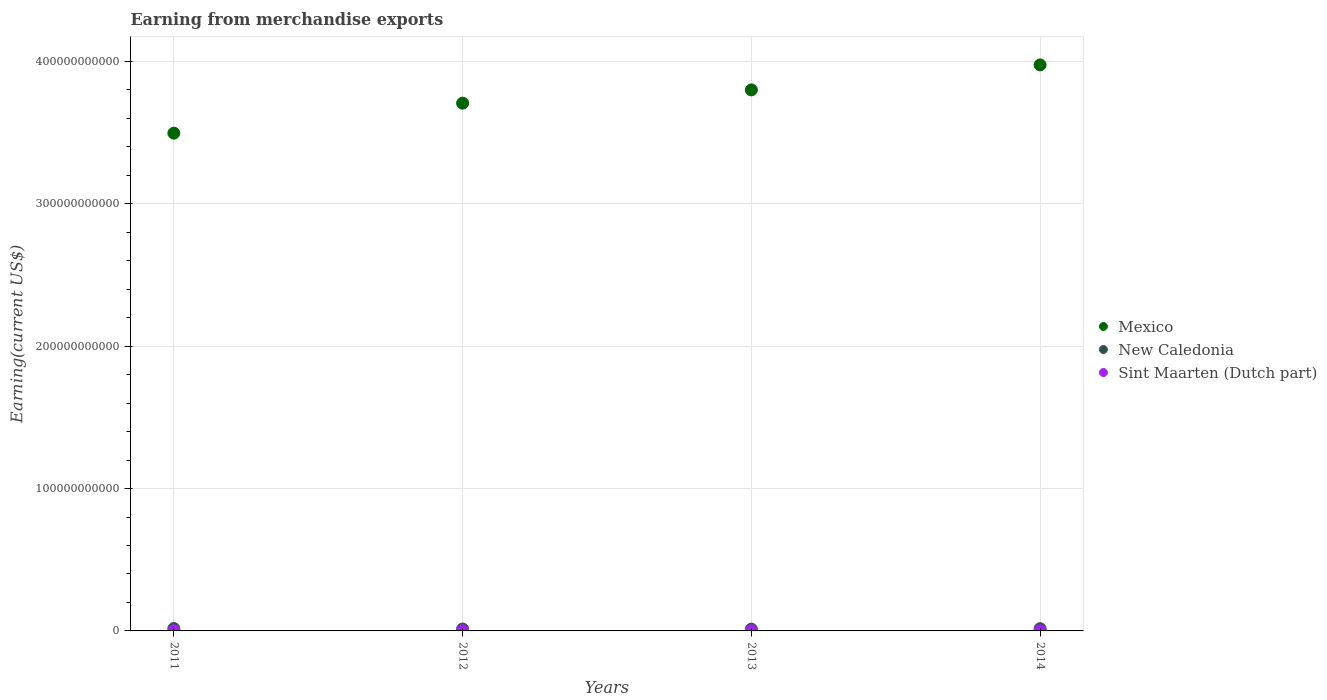How many different coloured dotlines are there?
Give a very brief answer. 3. Is the number of dotlines equal to the number of legend labels?
Provide a succinct answer. Yes. What is the amount earned from merchandise exports in Sint Maarten (Dutch part) in 2014?
Keep it short and to the point. 1.30e+08. Across all years, what is the maximum amount earned from merchandise exports in Mexico?
Ensure brevity in your answer.  3.98e+11. Across all years, what is the minimum amount earned from merchandise exports in New Caledonia?
Provide a succinct answer. 1.24e+09. In which year was the amount earned from merchandise exports in Mexico maximum?
Ensure brevity in your answer.  2014. In which year was the amount earned from merchandise exports in Mexico minimum?
Make the answer very short. 2011. What is the total amount earned from merchandise exports in New Caledonia in the graph?
Make the answer very short. 5.80e+09. What is the difference between the amount earned from merchandise exports in New Caledonia in 2013 and that in 2014?
Your response must be concise. -3.23e+08. What is the difference between the amount earned from merchandise exports in New Caledonia in 2011 and the amount earned from merchandise exports in Mexico in 2013?
Your response must be concise. -3.78e+11. What is the average amount earned from merchandise exports in New Caledonia per year?
Ensure brevity in your answer.  1.45e+09. In the year 2014, what is the difference between the amount earned from merchandise exports in New Caledonia and amount earned from merchandise exports in Sint Maarten (Dutch part)?
Your answer should be very brief. 1.43e+09. What is the ratio of the amount earned from merchandise exports in Mexico in 2013 to that in 2014?
Keep it short and to the point. 0.96. Is the amount earned from merchandise exports in New Caledonia in 2011 less than that in 2012?
Your answer should be compact. No. What is the difference between the highest and the second highest amount earned from merchandise exports in Sint Maarten (Dutch part)?
Make the answer very short. 4.63e+07. What is the difference between the highest and the lowest amount earned from merchandise exports in Sint Maarten (Dutch part)?
Your answer should be compact. 5.01e+07. Is the sum of the amount earned from merchandise exports in Mexico in 2012 and 2013 greater than the maximum amount earned from merchandise exports in Sint Maarten (Dutch part) across all years?
Provide a short and direct response. Yes. Is the amount earned from merchandise exports in New Caledonia strictly greater than the amount earned from merchandise exports in Sint Maarten (Dutch part) over the years?
Give a very brief answer. Yes. Is the amount earned from merchandise exports in New Caledonia strictly less than the amount earned from merchandise exports in Sint Maarten (Dutch part) over the years?
Provide a succinct answer. No. How many years are there in the graph?
Your answer should be very brief. 4. What is the difference between two consecutive major ticks on the Y-axis?
Your answer should be compact. 1.00e+11. Are the values on the major ticks of Y-axis written in scientific E-notation?
Your answer should be compact. No. Does the graph contain any zero values?
Provide a short and direct response. No. Where does the legend appear in the graph?
Provide a short and direct response. Center right. What is the title of the graph?
Offer a very short reply. Earning from merchandise exports. What is the label or title of the Y-axis?
Your answer should be compact. Earning(current US$). What is the Earning(current US$) of Mexico in 2011?
Your response must be concise. 3.50e+11. What is the Earning(current US$) of New Caledonia in 2011?
Your answer should be very brief. 1.66e+09. What is the Earning(current US$) in Sint Maarten (Dutch part) in 2011?
Offer a very short reply. 1.27e+08. What is the Earning(current US$) in Mexico in 2012?
Offer a very short reply. 3.71e+11. What is the Earning(current US$) in New Caledonia in 2012?
Make the answer very short. 1.33e+09. What is the Earning(current US$) in Sint Maarten (Dutch part) in 2012?
Your answer should be very brief. 1.31e+08. What is the Earning(current US$) of Mexico in 2013?
Offer a very short reply. 3.80e+11. What is the Earning(current US$) of New Caledonia in 2013?
Provide a short and direct response. 1.24e+09. What is the Earning(current US$) in Sint Maarten (Dutch part) in 2013?
Your response must be concise. 1.77e+08. What is the Earning(current US$) of Mexico in 2014?
Offer a very short reply. 3.98e+11. What is the Earning(current US$) of New Caledonia in 2014?
Offer a very short reply. 1.56e+09. What is the Earning(current US$) in Sint Maarten (Dutch part) in 2014?
Give a very brief answer. 1.30e+08. Across all years, what is the maximum Earning(current US$) of Mexico?
Ensure brevity in your answer.  3.98e+11. Across all years, what is the maximum Earning(current US$) of New Caledonia?
Give a very brief answer. 1.66e+09. Across all years, what is the maximum Earning(current US$) in Sint Maarten (Dutch part)?
Provide a succinct answer. 1.77e+08. Across all years, what is the minimum Earning(current US$) of Mexico?
Your answer should be compact. 3.50e+11. Across all years, what is the minimum Earning(current US$) in New Caledonia?
Make the answer very short. 1.24e+09. Across all years, what is the minimum Earning(current US$) of Sint Maarten (Dutch part)?
Give a very brief answer. 1.27e+08. What is the total Earning(current US$) in Mexico in the graph?
Your response must be concise. 1.50e+12. What is the total Earning(current US$) of New Caledonia in the graph?
Your response must be concise. 5.80e+09. What is the total Earning(current US$) in Sint Maarten (Dutch part) in the graph?
Offer a very short reply. 5.65e+08. What is the difference between the Earning(current US$) in Mexico in 2011 and that in 2012?
Your answer should be very brief. -2.11e+1. What is the difference between the Earning(current US$) of New Caledonia in 2011 and that in 2012?
Your answer should be very brief. 3.36e+08. What is the difference between the Earning(current US$) of Sint Maarten (Dutch part) in 2011 and that in 2012?
Ensure brevity in your answer.  -3.82e+06. What is the difference between the Earning(current US$) of Mexico in 2011 and that in 2013?
Ensure brevity in your answer.  -3.04e+1. What is the difference between the Earning(current US$) in New Caledonia in 2011 and that in 2013?
Give a very brief answer. 4.21e+08. What is the difference between the Earning(current US$) in Sint Maarten (Dutch part) in 2011 and that in 2013?
Provide a succinct answer. -5.01e+07. What is the difference between the Earning(current US$) in Mexico in 2011 and that in 2014?
Offer a very short reply. -4.80e+1. What is the difference between the Earning(current US$) in New Caledonia in 2011 and that in 2014?
Make the answer very short. 9.79e+07. What is the difference between the Earning(current US$) in Sint Maarten (Dutch part) in 2011 and that in 2014?
Your answer should be very brief. -3.09e+06. What is the difference between the Earning(current US$) in Mexico in 2012 and that in 2013?
Your answer should be compact. -9.32e+09. What is the difference between the Earning(current US$) in New Caledonia in 2012 and that in 2013?
Keep it short and to the point. 8.41e+07. What is the difference between the Earning(current US$) in Sint Maarten (Dutch part) in 2012 and that in 2013?
Provide a succinct answer. -4.63e+07. What is the difference between the Earning(current US$) in Mexico in 2012 and that in 2014?
Provide a short and direct response. -2.69e+1. What is the difference between the Earning(current US$) in New Caledonia in 2012 and that in 2014?
Your answer should be compact. -2.38e+08. What is the difference between the Earning(current US$) in Sint Maarten (Dutch part) in 2012 and that in 2014?
Keep it short and to the point. 7.26e+05. What is the difference between the Earning(current US$) in Mexico in 2013 and that in 2014?
Your answer should be compact. -1.76e+1. What is the difference between the Earning(current US$) in New Caledonia in 2013 and that in 2014?
Your response must be concise. -3.23e+08. What is the difference between the Earning(current US$) of Sint Maarten (Dutch part) in 2013 and that in 2014?
Ensure brevity in your answer.  4.70e+07. What is the difference between the Earning(current US$) in Mexico in 2011 and the Earning(current US$) in New Caledonia in 2012?
Provide a short and direct response. 3.48e+11. What is the difference between the Earning(current US$) in Mexico in 2011 and the Earning(current US$) in Sint Maarten (Dutch part) in 2012?
Provide a short and direct response. 3.49e+11. What is the difference between the Earning(current US$) in New Caledonia in 2011 and the Earning(current US$) in Sint Maarten (Dutch part) in 2012?
Offer a very short reply. 1.53e+09. What is the difference between the Earning(current US$) in Mexico in 2011 and the Earning(current US$) in New Caledonia in 2013?
Offer a terse response. 3.48e+11. What is the difference between the Earning(current US$) in Mexico in 2011 and the Earning(current US$) in Sint Maarten (Dutch part) in 2013?
Your response must be concise. 3.49e+11. What is the difference between the Earning(current US$) of New Caledonia in 2011 and the Earning(current US$) of Sint Maarten (Dutch part) in 2013?
Give a very brief answer. 1.49e+09. What is the difference between the Earning(current US$) in Mexico in 2011 and the Earning(current US$) in New Caledonia in 2014?
Provide a short and direct response. 3.48e+11. What is the difference between the Earning(current US$) in Mexico in 2011 and the Earning(current US$) in Sint Maarten (Dutch part) in 2014?
Provide a short and direct response. 3.49e+11. What is the difference between the Earning(current US$) of New Caledonia in 2011 and the Earning(current US$) of Sint Maarten (Dutch part) in 2014?
Provide a succinct answer. 1.53e+09. What is the difference between the Earning(current US$) of Mexico in 2012 and the Earning(current US$) of New Caledonia in 2013?
Make the answer very short. 3.69e+11. What is the difference between the Earning(current US$) in Mexico in 2012 and the Earning(current US$) in Sint Maarten (Dutch part) in 2013?
Your response must be concise. 3.70e+11. What is the difference between the Earning(current US$) in New Caledonia in 2012 and the Earning(current US$) in Sint Maarten (Dutch part) in 2013?
Offer a very short reply. 1.15e+09. What is the difference between the Earning(current US$) in Mexico in 2012 and the Earning(current US$) in New Caledonia in 2014?
Offer a very short reply. 3.69e+11. What is the difference between the Earning(current US$) of Mexico in 2012 and the Earning(current US$) of Sint Maarten (Dutch part) in 2014?
Ensure brevity in your answer.  3.71e+11. What is the difference between the Earning(current US$) in New Caledonia in 2012 and the Earning(current US$) in Sint Maarten (Dutch part) in 2014?
Your answer should be very brief. 1.20e+09. What is the difference between the Earning(current US$) of Mexico in 2013 and the Earning(current US$) of New Caledonia in 2014?
Offer a very short reply. 3.78e+11. What is the difference between the Earning(current US$) of Mexico in 2013 and the Earning(current US$) of Sint Maarten (Dutch part) in 2014?
Your answer should be compact. 3.80e+11. What is the difference between the Earning(current US$) in New Caledonia in 2013 and the Earning(current US$) in Sint Maarten (Dutch part) in 2014?
Your answer should be very brief. 1.11e+09. What is the average Earning(current US$) of Mexico per year?
Provide a short and direct response. 3.74e+11. What is the average Earning(current US$) in New Caledonia per year?
Offer a terse response. 1.45e+09. What is the average Earning(current US$) of Sint Maarten (Dutch part) per year?
Make the answer very short. 1.41e+08. In the year 2011, what is the difference between the Earning(current US$) in Mexico and Earning(current US$) in New Caledonia?
Provide a succinct answer. 3.48e+11. In the year 2011, what is the difference between the Earning(current US$) of Mexico and Earning(current US$) of Sint Maarten (Dutch part)?
Provide a succinct answer. 3.49e+11. In the year 2011, what is the difference between the Earning(current US$) of New Caledonia and Earning(current US$) of Sint Maarten (Dutch part)?
Keep it short and to the point. 1.54e+09. In the year 2012, what is the difference between the Earning(current US$) of Mexico and Earning(current US$) of New Caledonia?
Your answer should be very brief. 3.69e+11. In the year 2012, what is the difference between the Earning(current US$) in Mexico and Earning(current US$) in Sint Maarten (Dutch part)?
Your answer should be very brief. 3.71e+11. In the year 2012, what is the difference between the Earning(current US$) of New Caledonia and Earning(current US$) of Sint Maarten (Dutch part)?
Ensure brevity in your answer.  1.20e+09. In the year 2013, what is the difference between the Earning(current US$) of Mexico and Earning(current US$) of New Caledonia?
Offer a terse response. 3.79e+11. In the year 2013, what is the difference between the Earning(current US$) in Mexico and Earning(current US$) in Sint Maarten (Dutch part)?
Provide a short and direct response. 3.80e+11. In the year 2013, what is the difference between the Earning(current US$) in New Caledonia and Earning(current US$) in Sint Maarten (Dutch part)?
Provide a short and direct response. 1.07e+09. In the year 2014, what is the difference between the Earning(current US$) of Mexico and Earning(current US$) of New Caledonia?
Provide a succinct answer. 3.96e+11. In the year 2014, what is the difference between the Earning(current US$) of Mexico and Earning(current US$) of Sint Maarten (Dutch part)?
Offer a terse response. 3.97e+11. In the year 2014, what is the difference between the Earning(current US$) in New Caledonia and Earning(current US$) in Sint Maarten (Dutch part)?
Provide a short and direct response. 1.43e+09. What is the ratio of the Earning(current US$) in Mexico in 2011 to that in 2012?
Your response must be concise. 0.94. What is the ratio of the Earning(current US$) in New Caledonia in 2011 to that in 2012?
Provide a succinct answer. 1.25. What is the ratio of the Earning(current US$) of Sint Maarten (Dutch part) in 2011 to that in 2012?
Offer a very short reply. 0.97. What is the ratio of the Earning(current US$) of New Caledonia in 2011 to that in 2013?
Your answer should be very brief. 1.34. What is the ratio of the Earning(current US$) of Sint Maarten (Dutch part) in 2011 to that in 2013?
Make the answer very short. 0.72. What is the ratio of the Earning(current US$) of Mexico in 2011 to that in 2014?
Give a very brief answer. 0.88. What is the ratio of the Earning(current US$) in New Caledonia in 2011 to that in 2014?
Keep it short and to the point. 1.06. What is the ratio of the Earning(current US$) in Sint Maarten (Dutch part) in 2011 to that in 2014?
Your answer should be very brief. 0.98. What is the ratio of the Earning(current US$) in Mexico in 2012 to that in 2013?
Make the answer very short. 0.98. What is the ratio of the Earning(current US$) in New Caledonia in 2012 to that in 2013?
Your response must be concise. 1.07. What is the ratio of the Earning(current US$) of Sint Maarten (Dutch part) in 2012 to that in 2013?
Offer a terse response. 0.74. What is the ratio of the Earning(current US$) in Mexico in 2012 to that in 2014?
Ensure brevity in your answer.  0.93. What is the ratio of the Earning(current US$) in New Caledonia in 2012 to that in 2014?
Give a very brief answer. 0.85. What is the ratio of the Earning(current US$) in Sint Maarten (Dutch part) in 2012 to that in 2014?
Provide a succinct answer. 1.01. What is the ratio of the Earning(current US$) of Mexico in 2013 to that in 2014?
Ensure brevity in your answer.  0.96. What is the ratio of the Earning(current US$) in New Caledonia in 2013 to that in 2014?
Offer a very short reply. 0.79. What is the ratio of the Earning(current US$) in Sint Maarten (Dutch part) in 2013 to that in 2014?
Your answer should be compact. 1.36. What is the difference between the highest and the second highest Earning(current US$) in Mexico?
Provide a succinct answer. 1.76e+1. What is the difference between the highest and the second highest Earning(current US$) in New Caledonia?
Your answer should be very brief. 9.79e+07. What is the difference between the highest and the second highest Earning(current US$) of Sint Maarten (Dutch part)?
Give a very brief answer. 4.63e+07. What is the difference between the highest and the lowest Earning(current US$) of Mexico?
Provide a succinct answer. 4.80e+1. What is the difference between the highest and the lowest Earning(current US$) in New Caledonia?
Make the answer very short. 4.21e+08. What is the difference between the highest and the lowest Earning(current US$) of Sint Maarten (Dutch part)?
Offer a terse response. 5.01e+07. 